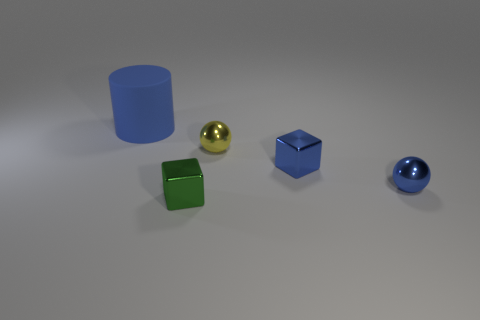Does the small green thing have the same material as the block right of the tiny green block?
Provide a short and direct response. Yes. Is the number of large blue matte things right of the tiny green cube less than the number of tiny yellow metallic things?
Your response must be concise. Yes. How many other things are there of the same shape as the large blue object?
Your response must be concise. 0. Is there any other thing that is the same color as the big matte cylinder?
Ensure brevity in your answer.  Yes. Do the large matte thing and the object that is in front of the blue sphere have the same color?
Your answer should be compact. No. How many other things are there of the same size as the green object?
Offer a very short reply. 3. The cube that is the same color as the big cylinder is what size?
Give a very brief answer. Small. How many cylinders are either small green shiny objects or tiny yellow metallic things?
Offer a very short reply. 0. Does the blue thing left of the green object have the same shape as the green metal object?
Keep it short and to the point. No. Is the number of yellow metallic things left of the yellow shiny object greater than the number of things?
Provide a short and direct response. No. 